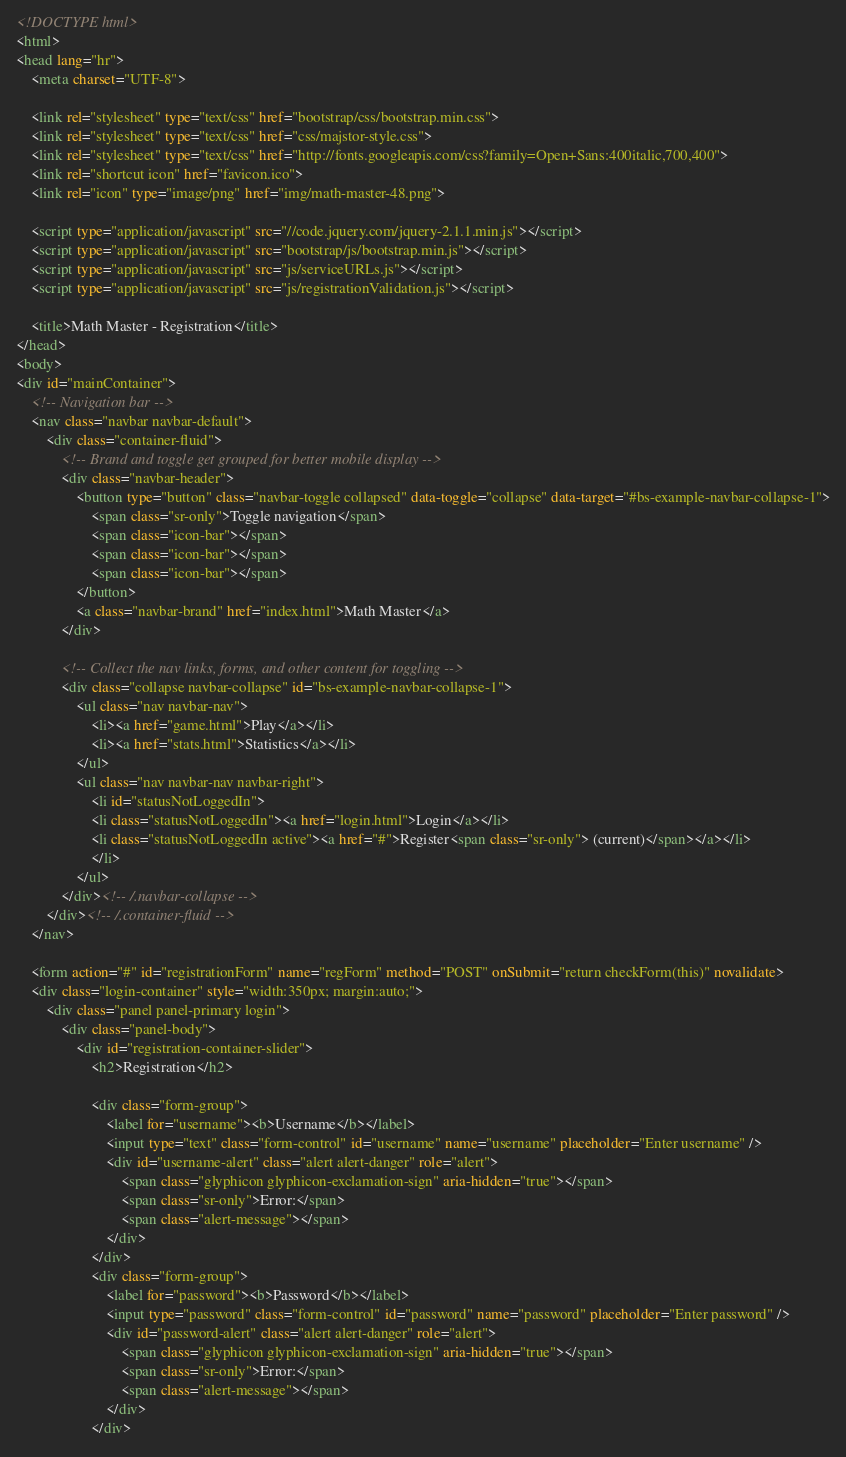Convert code to text. <code><loc_0><loc_0><loc_500><loc_500><_HTML_><!DOCTYPE html>
<html>
<head lang="hr">
    <meta charset="UTF-8">

    <link rel="stylesheet" type="text/css" href="bootstrap/css/bootstrap.min.css">
    <link rel="stylesheet" type="text/css" href="css/majstor-style.css">
    <link rel="stylesheet" type="text/css" href="http://fonts.googleapis.com/css?family=Open+Sans:400italic,700,400">
    <link rel="shortcut icon" href="favicon.ico">
	<link rel="icon" type="image/png" href="img/math-master-48.png">

	<script type="application/javascript" src="//code.jquery.com/jquery-2.1.1.min.js"></script>
    <script type="application/javascript" src="bootstrap/js/bootstrap.min.js"></script>
	<script type="application/javascript" src="js/serviceURLs.js"></script>
    <script type="application/javascript" src="js/registrationValidation.js"></script>
    
    <title>Math Master - Registration</title>
</head>
<body>
<div id="mainContainer">
	<!-- Navigation bar -->
	<nav class="navbar navbar-default">
		<div class="container-fluid">
			<!-- Brand and toggle get grouped for better mobile display -->
			<div class="navbar-header">
				<button type="button" class="navbar-toggle collapsed" data-toggle="collapse" data-target="#bs-example-navbar-collapse-1">
					<span class="sr-only">Toggle navigation</span>
					<span class="icon-bar"></span>
					<span class="icon-bar"></span>
					<span class="icon-bar"></span>
				</button>
				<a class="navbar-brand" href="index.html">Math Master</a>
			</div>

			<!-- Collect the nav links, forms, and other content for toggling -->
			<div class="collapse navbar-collapse" id="bs-example-navbar-collapse-1">
				<ul class="nav navbar-nav">
					<li><a href="game.html">Play</a></li>
					<li><a href="stats.html">Statistics</a></li>
				</ul>
				<ul class="nav navbar-nav navbar-right">
					<li id="statusNotLoggedIn">
					<li class="statusNotLoggedIn"><a href="login.html">Login</a></li>
					<li class="statusNotLoggedIn active"><a href="#">Register<span class="sr-only"> (current)</span></a></li>
					</li>
				</ul>
			</div><!-- /.navbar-collapse -->
		</div><!-- /.container-fluid -->
	</nav>

	<form action="#" id="registrationForm" name="regForm" method="POST" onSubmit="return checkForm(this)" novalidate>
	<div class="login-container" style="width:350px; margin:auto;">
		<div class="panel panel-primary login">
			<div class="panel-body">
				<div id="registration-container-slider">
					<h2>Registration</h2>

					<div class="form-group">
						<label for="username"><b>Username</b></label>
						<input type="text" class="form-control" id="username" name="username" placeholder="Enter username" />
						<div id="username-alert" class="alert alert-danger" role="alert">
							<span class="glyphicon glyphicon-exclamation-sign" aria-hidden="true"></span>
							<span class="sr-only">Error:</span>
							<span class="alert-message"></span>
						</div>
					</div>
					<div class="form-group">
						<label for="password"><b>Password</b></label>
						<input type="password" class="form-control" id="password" name="password" placeholder="Enter password" />
						<div id="password-alert" class="alert alert-danger" role="alert">
							<span class="glyphicon glyphicon-exclamation-sign" aria-hidden="true"></span>
							<span class="sr-only">Error:</span>
							<span class="alert-message"></span>
						</div>
					</div></code> 